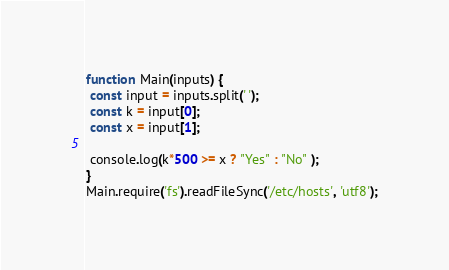<code> <loc_0><loc_0><loc_500><loc_500><_JavaScript_>function Main(inputs) {
 const input = inputs.split(' ');
 const k = input[0];
 const x = input[1];

 console.log(k*500 >= x ? "Yes" : "No" );
}
Main.require('fs').readFileSync('/etc/hosts', 'utf8');</code> 